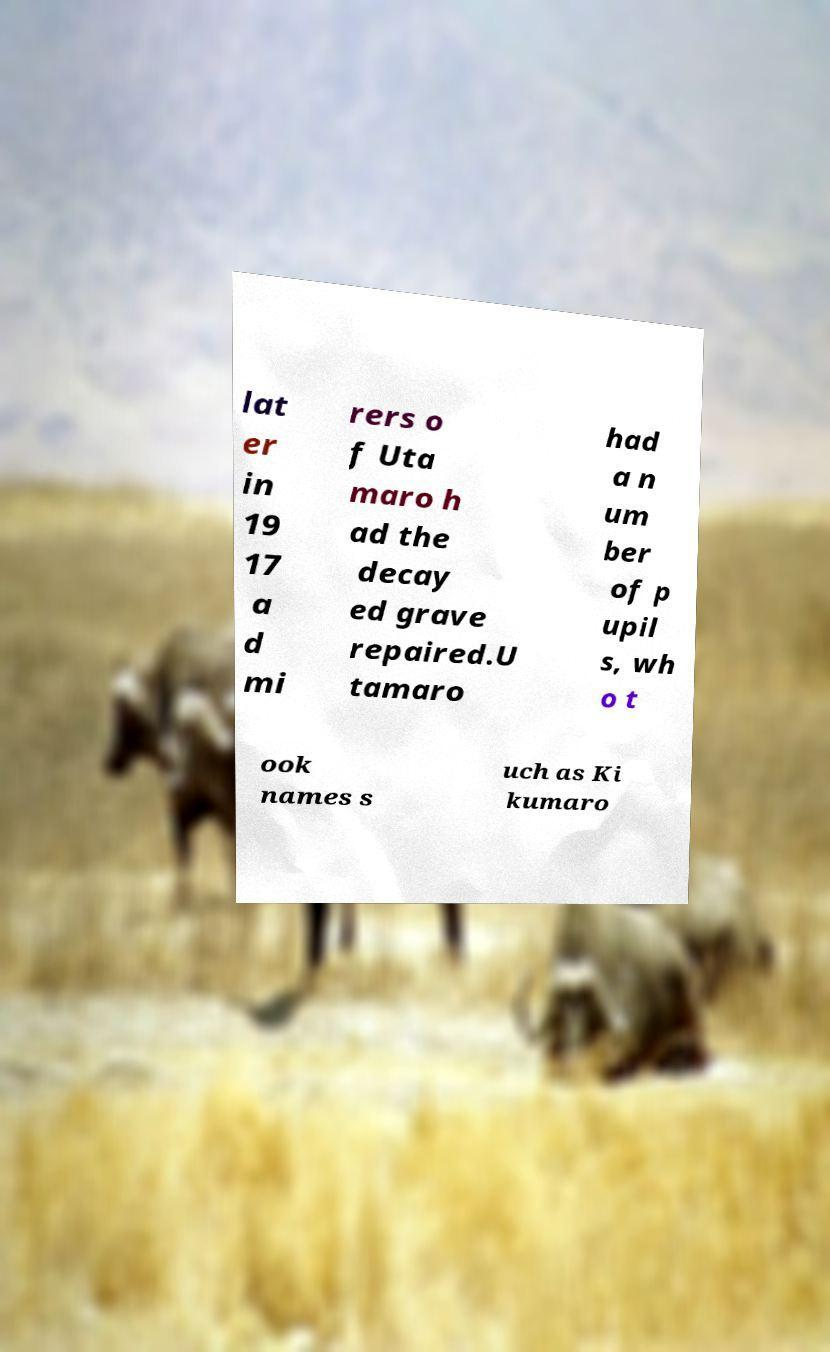What messages or text are displayed in this image? I need them in a readable, typed format. lat er in 19 17 a d mi rers o f Uta maro h ad the decay ed grave repaired.U tamaro had a n um ber of p upil s, wh o t ook names s uch as Ki kumaro 